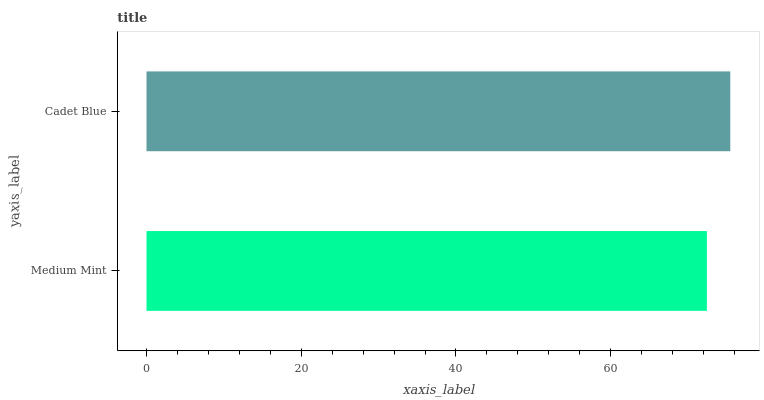Is Medium Mint the minimum?
Answer yes or no. Yes. Is Cadet Blue the maximum?
Answer yes or no. Yes. Is Cadet Blue the minimum?
Answer yes or no. No. Is Cadet Blue greater than Medium Mint?
Answer yes or no. Yes. Is Medium Mint less than Cadet Blue?
Answer yes or no. Yes. Is Medium Mint greater than Cadet Blue?
Answer yes or no. No. Is Cadet Blue less than Medium Mint?
Answer yes or no. No. Is Cadet Blue the high median?
Answer yes or no. Yes. Is Medium Mint the low median?
Answer yes or no. Yes. Is Medium Mint the high median?
Answer yes or no. No. Is Cadet Blue the low median?
Answer yes or no. No. 